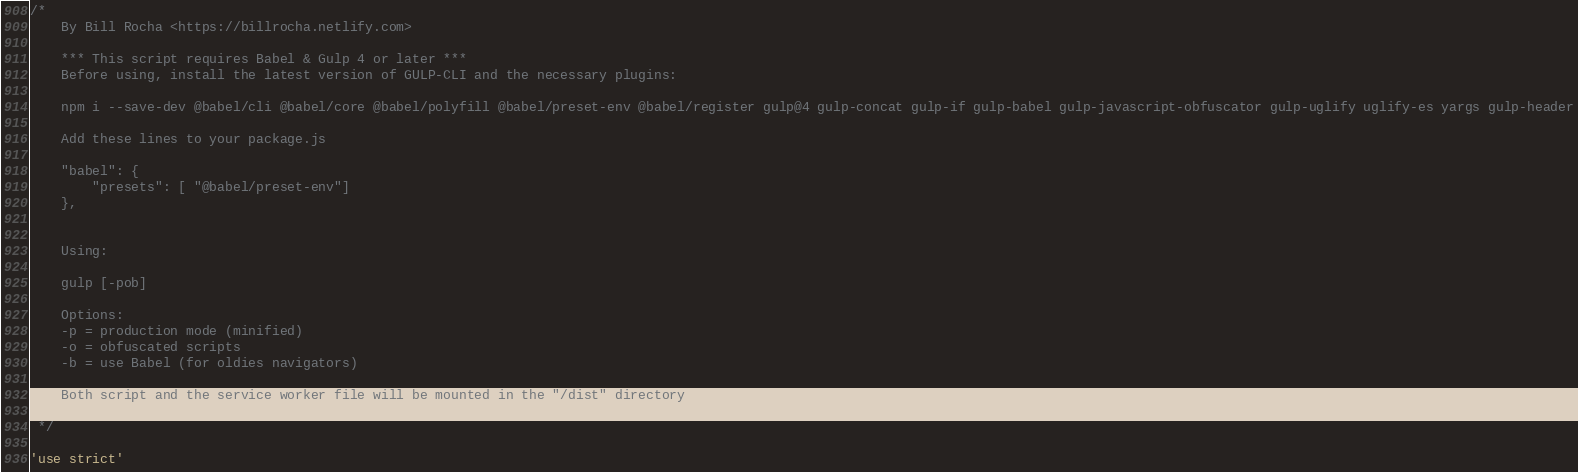<code> <loc_0><loc_0><loc_500><loc_500><_JavaScript_>/*  
    By Bill Rocha <https://billrocha.netlify.com>

	*** This script requires Babel & Gulp 4 or later *** 
    Before using, install the latest version of GULP-CLI and the necessary plugins:

    npm i --save-dev @babel/cli @babel/core @babel/polyfill @babel/preset-env @babel/register gulp@4 gulp-concat gulp-if gulp-babel gulp-javascript-obfuscator gulp-uglify uglify-es yargs gulp-header

    Add these lines to your package.js

    "babel": {
        "presets": [ "@babel/preset-env"]
	},
	

	Using:

	gulp [-pob]

	Options:
	-p = production mode (minified)	
	-o = obfuscated scripts	
	-b = use Babel (for oldies navigators)

	Both script and the service worker file will be mounted in the "/dist" directory

 */

'use strict'
</code> 